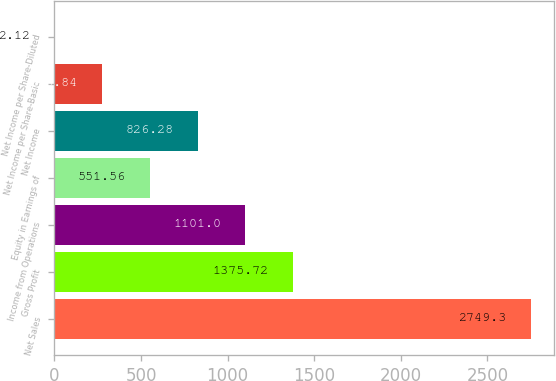Convert chart to OTSL. <chart><loc_0><loc_0><loc_500><loc_500><bar_chart><fcel>Net Sales<fcel>Gross Profit<fcel>Income from Operations<fcel>Equity in Earnings of<fcel>Net Income<fcel>Net Income per Share-Basic<fcel>Net Income per Share-Diluted<nl><fcel>2749.3<fcel>1375.72<fcel>1101<fcel>551.56<fcel>826.28<fcel>276.84<fcel>2.12<nl></chart> 